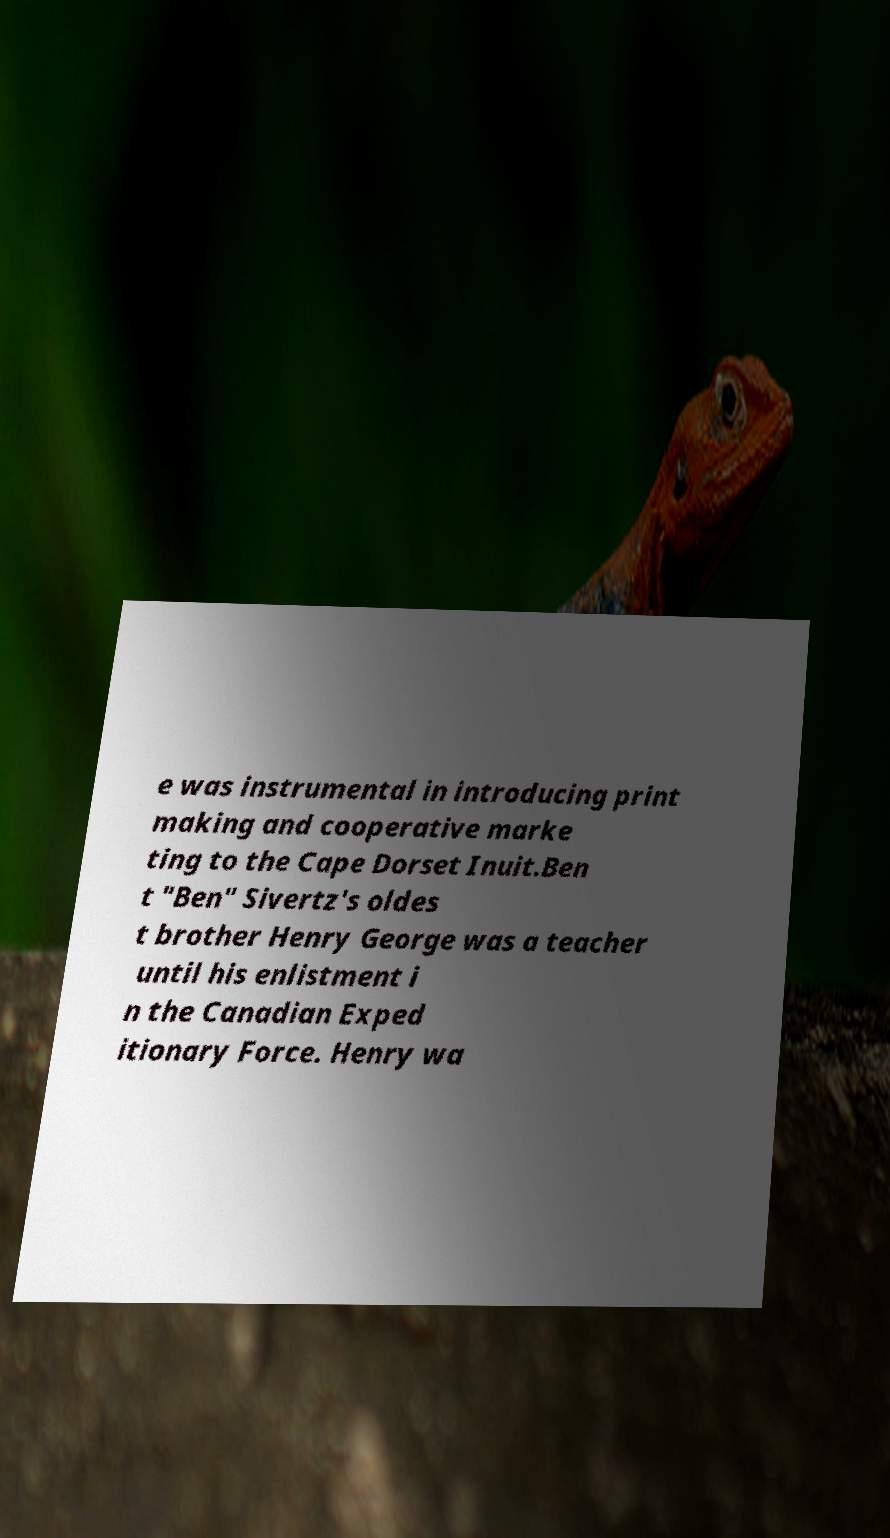I need the written content from this picture converted into text. Can you do that? e was instrumental in introducing print making and cooperative marke ting to the Cape Dorset Inuit.Ben t "Ben" Sivertz's oldes t brother Henry George was a teacher until his enlistment i n the Canadian Exped itionary Force. Henry wa 